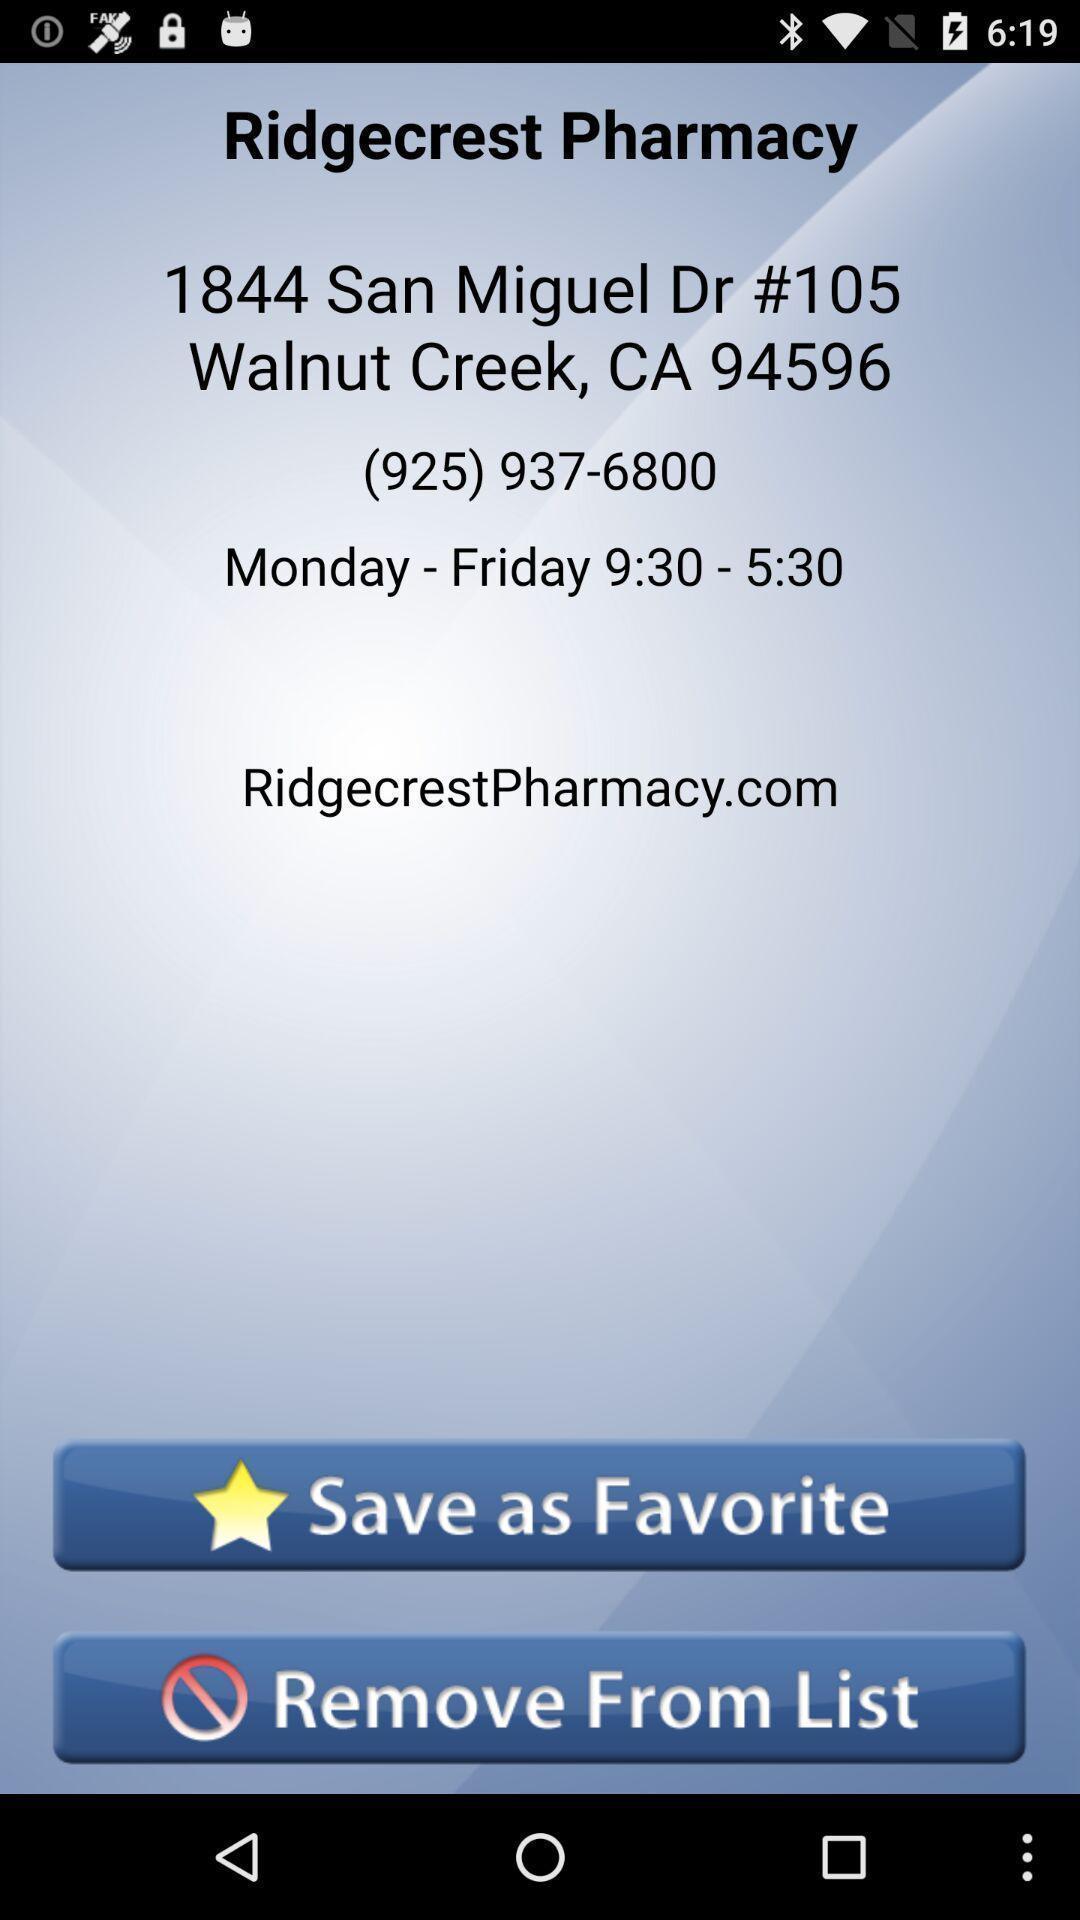Tell me what you see in this picture. Screen shows address details of a health app. 